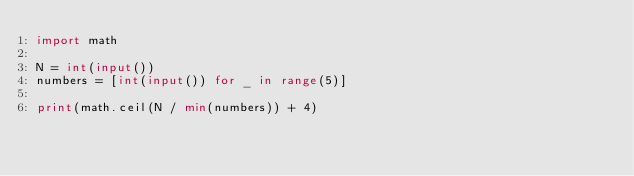Convert code to text. <code><loc_0><loc_0><loc_500><loc_500><_Python_>import math

N = int(input())
numbers = [int(input()) for _ in range(5)]

print(math.ceil(N / min(numbers)) + 4)</code> 